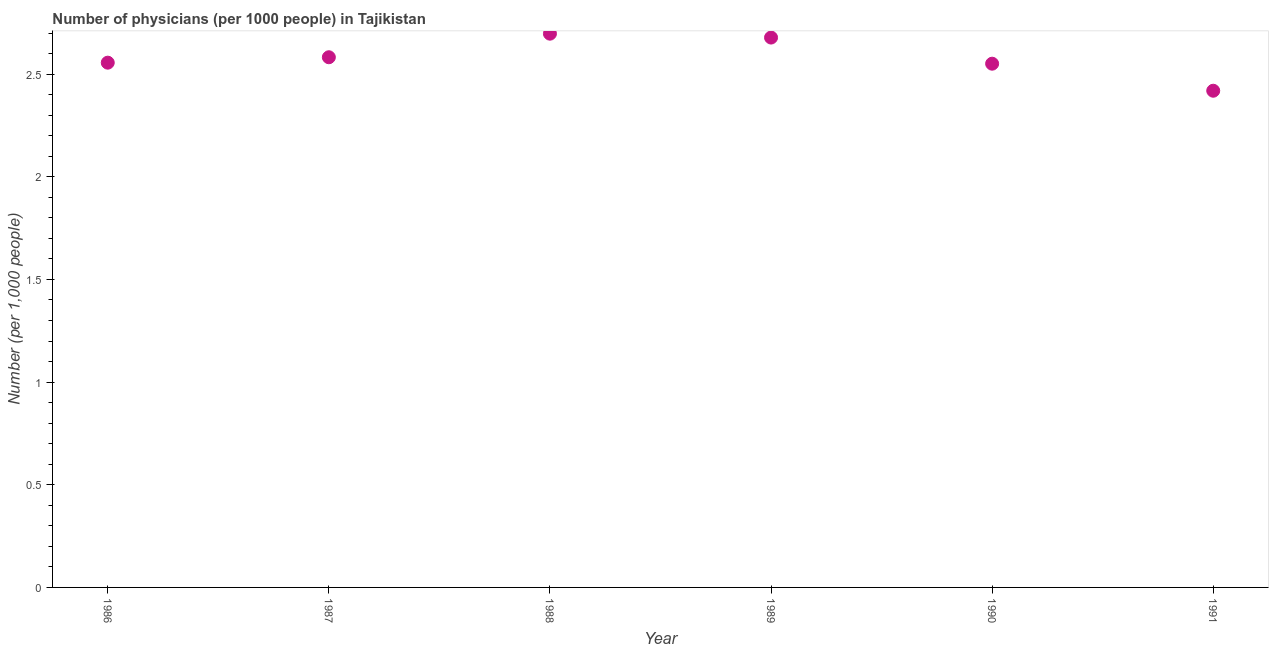What is the number of physicians in 1986?
Your answer should be very brief. 2.56. Across all years, what is the maximum number of physicians?
Keep it short and to the point. 2.7. Across all years, what is the minimum number of physicians?
Your answer should be compact. 2.42. In which year was the number of physicians maximum?
Offer a very short reply. 1988. In which year was the number of physicians minimum?
Offer a terse response. 1991. What is the sum of the number of physicians?
Provide a short and direct response. 15.48. What is the difference between the number of physicians in 1986 and 1988?
Give a very brief answer. -0.14. What is the average number of physicians per year?
Your answer should be very brief. 2.58. What is the median number of physicians?
Keep it short and to the point. 2.57. In how many years, is the number of physicians greater than 0.6 ?
Offer a very short reply. 6. Do a majority of the years between 1991 and 1989 (inclusive) have number of physicians greater than 1.8 ?
Your response must be concise. No. What is the ratio of the number of physicians in 1986 to that in 1991?
Provide a short and direct response. 1.06. Is the number of physicians in 1989 less than that in 1991?
Give a very brief answer. No. Is the difference between the number of physicians in 1988 and 1991 greater than the difference between any two years?
Make the answer very short. Yes. What is the difference between the highest and the second highest number of physicians?
Provide a succinct answer. 0.02. What is the difference between the highest and the lowest number of physicians?
Make the answer very short. 0.28. In how many years, is the number of physicians greater than the average number of physicians taken over all years?
Your answer should be compact. 3. Does the number of physicians monotonically increase over the years?
Ensure brevity in your answer.  No. How many dotlines are there?
Give a very brief answer. 1. Does the graph contain grids?
Offer a terse response. No. What is the title of the graph?
Your response must be concise. Number of physicians (per 1000 people) in Tajikistan. What is the label or title of the X-axis?
Your answer should be very brief. Year. What is the label or title of the Y-axis?
Offer a very short reply. Number (per 1,0 people). What is the Number (per 1,000 people) in 1986?
Offer a terse response. 2.56. What is the Number (per 1,000 people) in 1987?
Provide a short and direct response. 2.58. What is the Number (per 1,000 people) in 1988?
Your response must be concise. 2.7. What is the Number (per 1,000 people) in 1989?
Ensure brevity in your answer.  2.68. What is the Number (per 1,000 people) in 1990?
Your answer should be compact. 2.55. What is the Number (per 1,000 people) in 1991?
Keep it short and to the point. 2.42. What is the difference between the Number (per 1,000 people) in 1986 and 1987?
Offer a very short reply. -0.03. What is the difference between the Number (per 1,000 people) in 1986 and 1988?
Make the answer very short. -0.14. What is the difference between the Number (per 1,000 people) in 1986 and 1989?
Your answer should be very brief. -0.12. What is the difference between the Number (per 1,000 people) in 1986 and 1990?
Provide a short and direct response. 0.01. What is the difference between the Number (per 1,000 people) in 1986 and 1991?
Offer a very short reply. 0.14. What is the difference between the Number (per 1,000 people) in 1987 and 1988?
Your answer should be compact. -0.11. What is the difference between the Number (per 1,000 people) in 1987 and 1989?
Ensure brevity in your answer.  -0.1. What is the difference between the Number (per 1,000 people) in 1987 and 1990?
Offer a terse response. 0.03. What is the difference between the Number (per 1,000 people) in 1987 and 1991?
Ensure brevity in your answer.  0.16. What is the difference between the Number (per 1,000 people) in 1988 and 1989?
Offer a very short reply. 0.02. What is the difference between the Number (per 1,000 people) in 1988 and 1990?
Your answer should be very brief. 0.15. What is the difference between the Number (per 1,000 people) in 1988 and 1991?
Your answer should be compact. 0.28. What is the difference between the Number (per 1,000 people) in 1989 and 1990?
Offer a very short reply. 0.13. What is the difference between the Number (per 1,000 people) in 1989 and 1991?
Provide a succinct answer. 0.26. What is the difference between the Number (per 1,000 people) in 1990 and 1991?
Offer a terse response. 0.13. What is the ratio of the Number (per 1,000 people) in 1986 to that in 1987?
Your answer should be compact. 0.99. What is the ratio of the Number (per 1,000 people) in 1986 to that in 1988?
Keep it short and to the point. 0.95. What is the ratio of the Number (per 1,000 people) in 1986 to that in 1989?
Ensure brevity in your answer.  0.95. What is the ratio of the Number (per 1,000 people) in 1986 to that in 1991?
Ensure brevity in your answer.  1.06. What is the ratio of the Number (per 1,000 people) in 1987 to that in 1988?
Your response must be concise. 0.96. What is the ratio of the Number (per 1,000 people) in 1987 to that in 1990?
Your answer should be compact. 1.01. What is the ratio of the Number (per 1,000 people) in 1987 to that in 1991?
Give a very brief answer. 1.07. What is the ratio of the Number (per 1,000 people) in 1988 to that in 1989?
Give a very brief answer. 1.01. What is the ratio of the Number (per 1,000 people) in 1988 to that in 1990?
Ensure brevity in your answer.  1.06. What is the ratio of the Number (per 1,000 people) in 1988 to that in 1991?
Give a very brief answer. 1.11. What is the ratio of the Number (per 1,000 people) in 1989 to that in 1990?
Offer a very short reply. 1.05. What is the ratio of the Number (per 1,000 people) in 1989 to that in 1991?
Offer a very short reply. 1.11. What is the ratio of the Number (per 1,000 people) in 1990 to that in 1991?
Give a very brief answer. 1.05. 